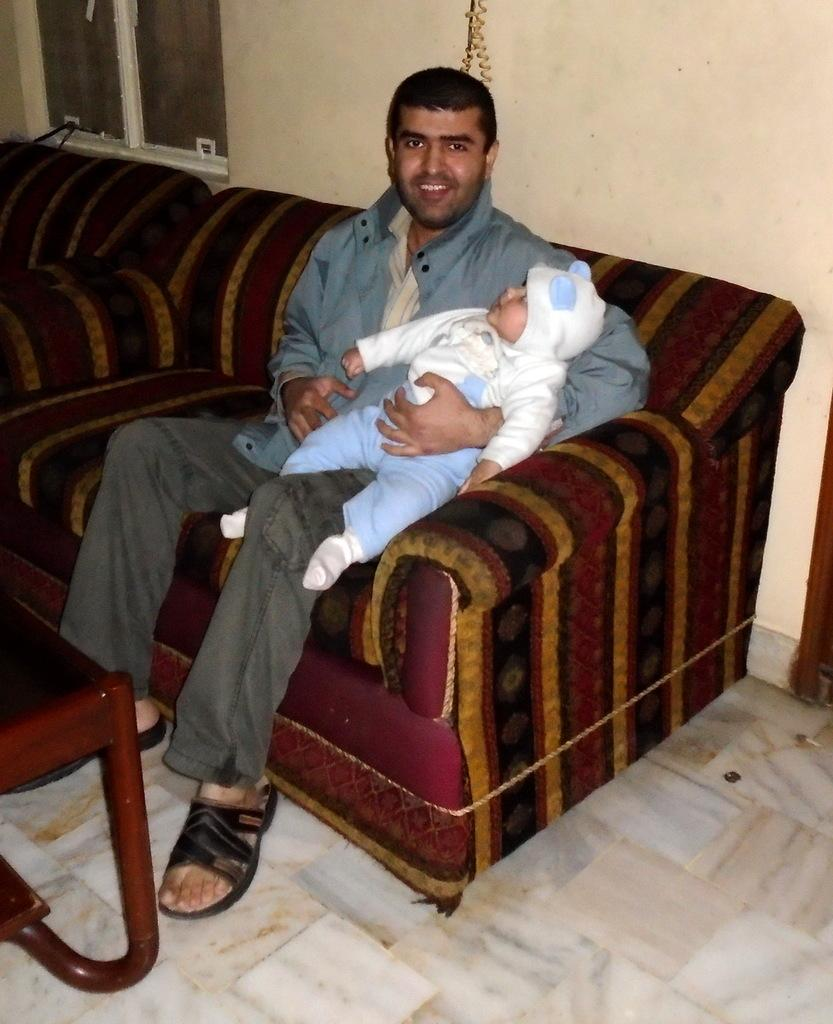Who is the main subject in the image? There is a person in the image. What is the person doing in the image? The person is holding a baby. Where is the person sitting in the image? The person is sitting on a sofa. How is the sofa positioned in the image? The sofa is placed on the ground. What can be seen in the background of the image? There is a table and a window in the background of the image. What type of oranges can be seen on the table in the image? There are no oranges present in the image; only a table and a window can be seen in the background. How old is the boy in the image? There is no boy present in the image; the main subject is a person holding a baby. 